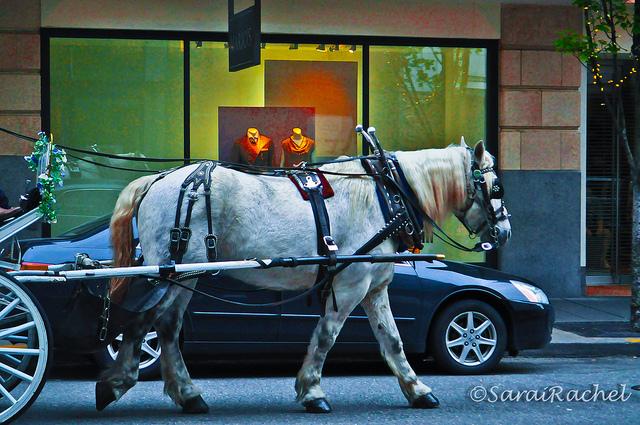How many cars are here?
Keep it brief. 1. What is the horse pulling?
Concise answer only. Cart. What time of year is this?
Give a very brief answer. Winter. 